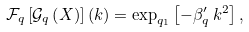<formula> <loc_0><loc_0><loc_500><loc_500>\mathcal { F } _ { q } \left [ \mathcal { G } _ { q } \left ( X \right ) \right ] \left ( k \right ) = \exp _ { q _ { 1 } } \left [ - \beta _ { q } ^ { \prime } \, k ^ { 2 } \right ] ,</formula> 